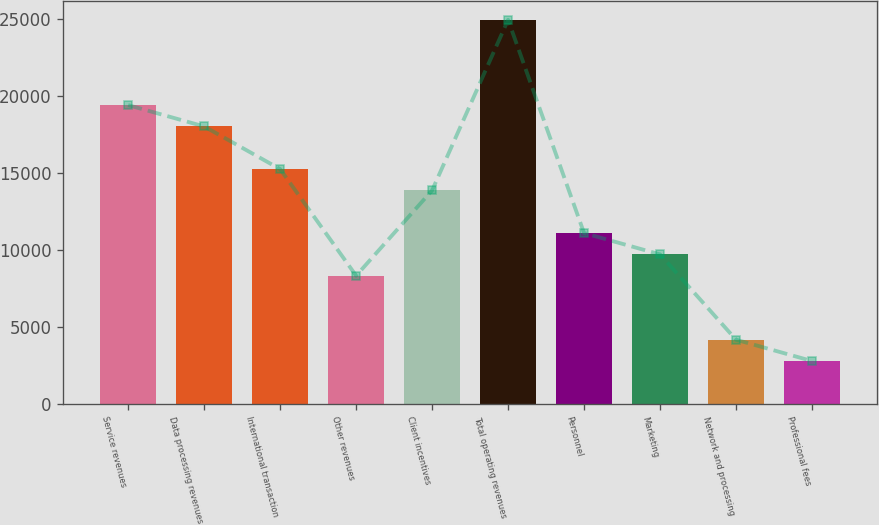Convert chart. <chart><loc_0><loc_0><loc_500><loc_500><bar_chart><fcel>Service revenues<fcel>Data processing revenues<fcel>International transaction<fcel>Other revenues<fcel>Client incentives<fcel>Total operating revenues<fcel>Personnel<fcel>Marketing<fcel>Network and processing<fcel>Professional fees<nl><fcel>19426.4<fcel>18039.8<fcel>15266.6<fcel>8333.6<fcel>13880<fcel>24972.8<fcel>11106.8<fcel>9720.2<fcel>4173.8<fcel>2787.2<nl></chart> 